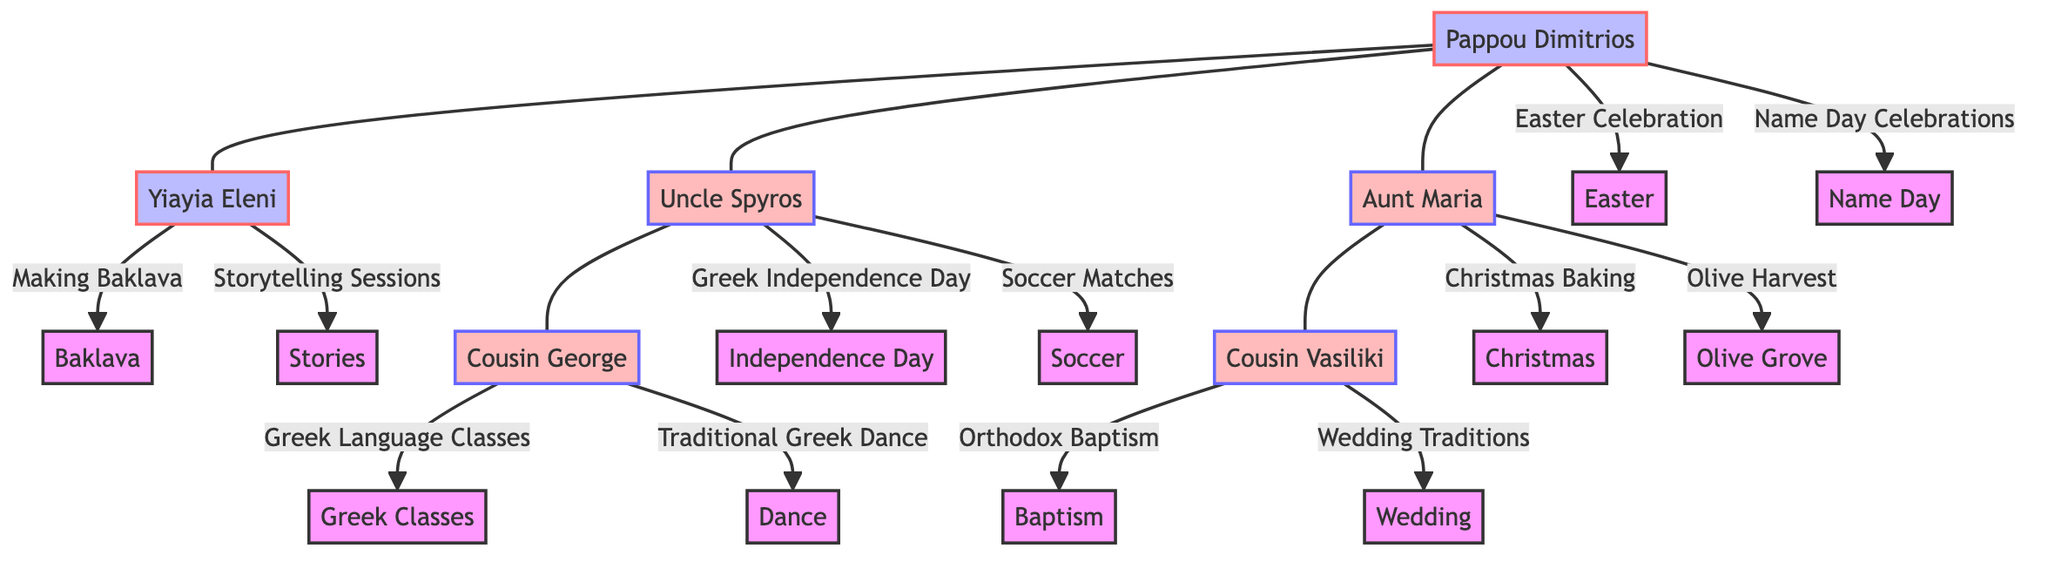What customs are associated with Pappou Dimitrios? The nodes connected to Pappou Dimitrios indicate two customs: "Easter Celebration" and "Name Day Celebrations."
Answer: Easter Celebration, Name Day Celebrations How many cousins are represented in the family tree? Counting the nodes representing cousins, there are two: Cousin George and Cousin Vasiliki.
Answer: 2 Which family member has a custom related to Greek Independence Day? Tracing the connection from the corresponding node, "Uncle Spyros" is directly linked to the custom "Greek Independence Day."
Answer: Uncle Spyros What holiday does Aunt Maria celebrate through baking? By examining Aunt Maria's customs, "Christmas Baking" is the relevant holiday celebrated through this practice.
Answer: Christmas Baking What custom does Cousin Vasiliki participate in related to weddings? The node for Cousin Vasiliki specifies the custom "Wedding Traditions," which pertains to weddings.
Answer: Wedding Traditions Which family member's customs include storytelling sessions? The node for Yiayia Eleni lists "Storytelling Sessions," indicating that this family member engages in this custom.
Answer: Yiayia Eleni How many customs does Uncle Spyros have? Two customs are directly associated with Uncle Spyros: "Greek Independence Day" and "Soccer Matches."
Answer: 2 What is the connection between Cousin George and Greek Language Classes? Cousin George's node specifies "Greek Language Classes," demonstrating a direct connection to this educational custom.
Answer: Greek Language Classes Which family member participates in traditional Greek dance? The node for Cousin George shows a custom named "Traditional Greek Dance," indicating his participation.
Answer: Cousin George 